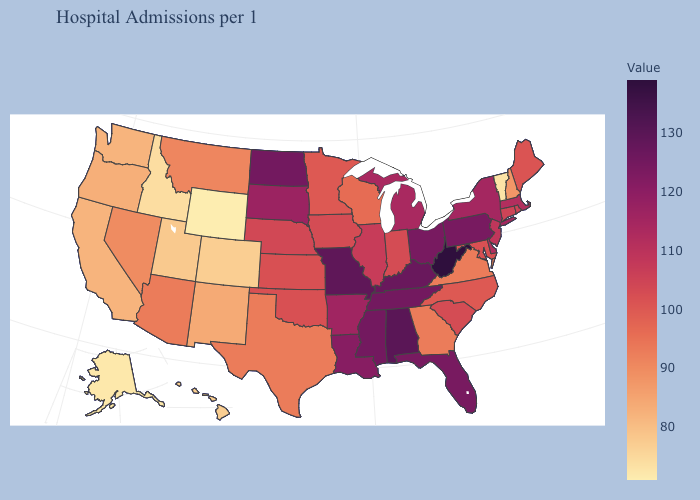Does North Dakota have a higher value than Kansas?
Keep it brief. Yes. Among the states that border Vermont , does Massachusetts have the lowest value?
Give a very brief answer. No. Which states have the lowest value in the South?
Write a very short answer. Georgia, Texas, Virginia. Which states have the highest value in the USA?
Keep it brief. West Virginia. Does Georgia have a higher value than Florida?
Write a very short answer. No. Which states hav the highest value in the West?
Short answer required. Arizona. Does Minnesota have a higher value than Louisiana?
Quick response, please. No. 